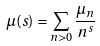Convert formula to latex. <formula><loc_0><loc_0><loc_500><loc_500>\mu ( s ) & = \sum _ { n > 0 } \frac { \mu _ { n } } { n ^ { s } }</formula> 